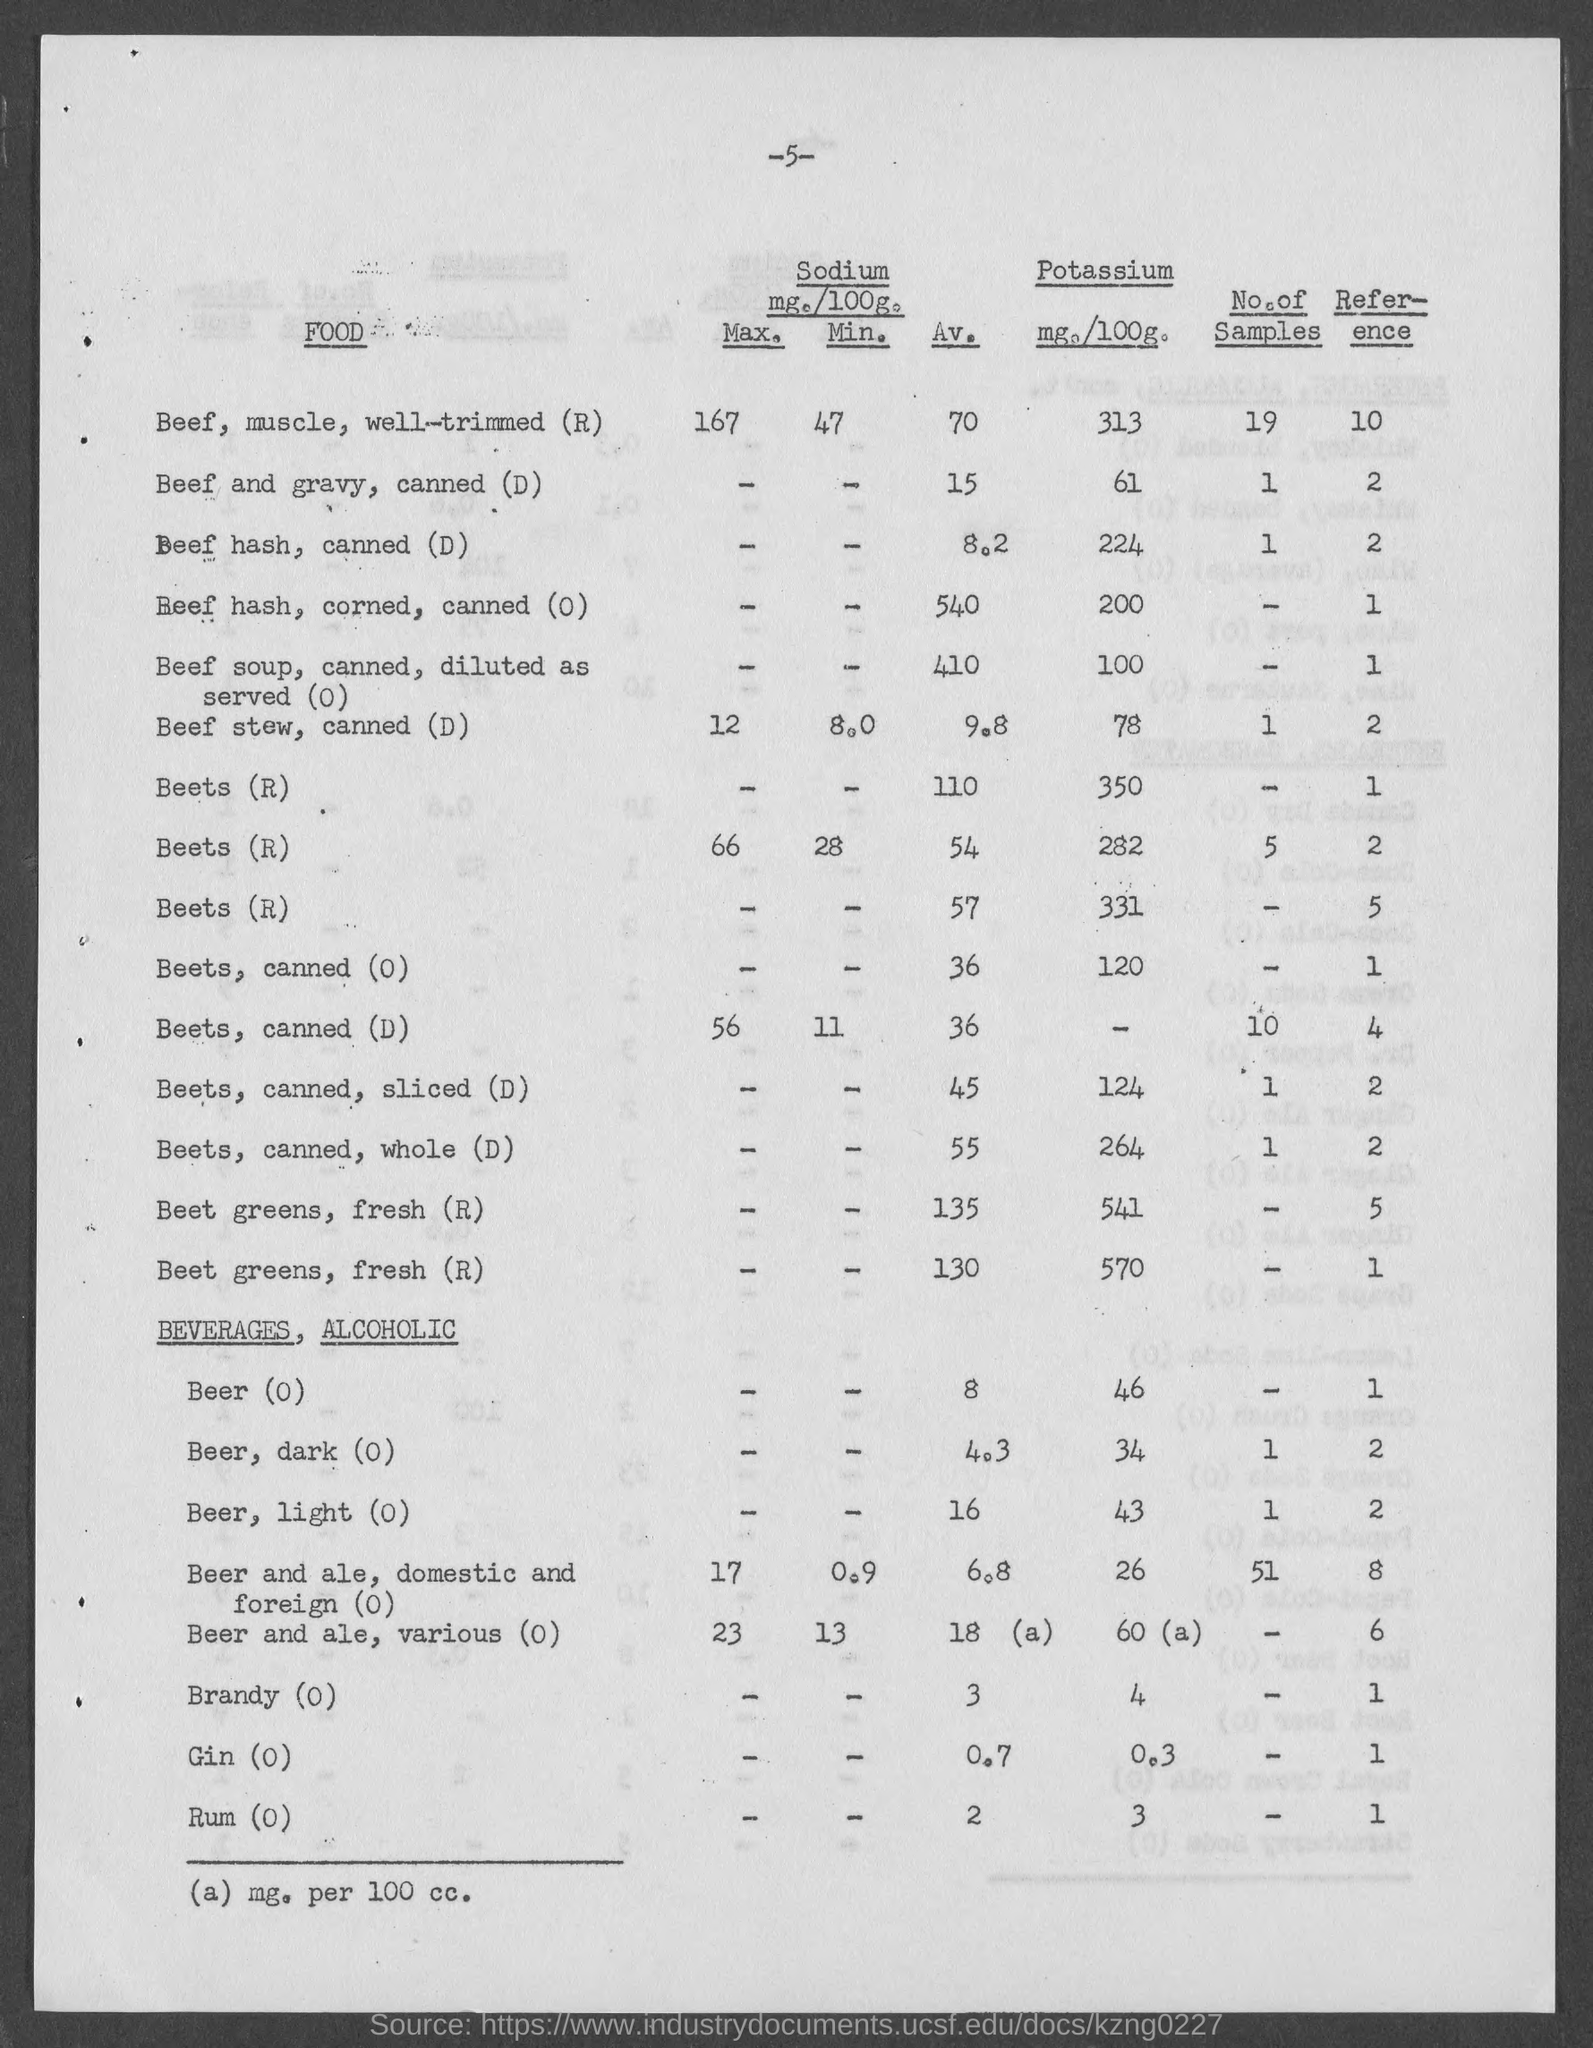Mention a couple of crucial points in this snapshot. The amount of potassium in a serving of canned, sliced beets is 124 milligrams, according to the nutrition information for the D variety. The potassium content of canned, whole beets is 264 milligrams per serving. The average sodium content for canned beets (variation D) is 36 milligrams per 100 grams. The average sodium content for canned, sliced beets (D) is 45 milligrams per serving. The average sodium content for beer is 8 mg per 100 ml, for beers with no added sodium. 